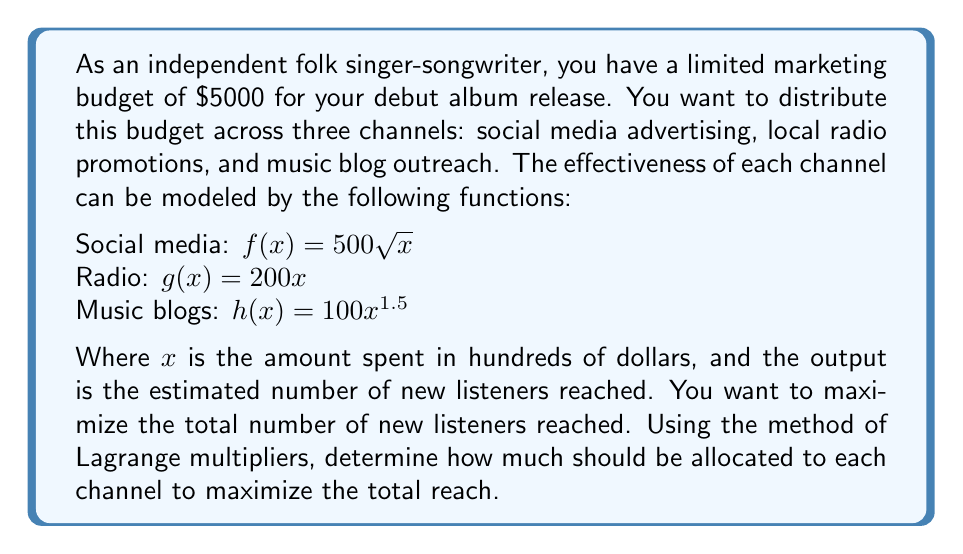What is the answer to this math problem? Let's approach this step-by-step using the method of Lagrange multipliers:

1) Let $x$, $y$, and $z$ represent the amount spent (in hundreds of dollars) on social media, radio, and music blogs respectively.

2) Our objective function is:
   $$F(x,y,z) = 500\sqrt{x} + 200y + 100z^{1.5}$$

3) Our constraint is:
   $$x + y + z = 50$$ (since the total budget is $5000 = 50 * 100$)

4) We form the Lagrangian:
   $$L(x,y,z,\lambda) = 500\sqrt{x} + 200y + 100z^{1.5} - \lambda(x + y + z - 50)$$

5) Now we take partial derivatives and set them equal to zero:

   $$\frac{\partial L}{\partial x} = \frac{250}{\sqrt{x}} - \lambda = 0$$
   $$\frac{\partial L}{\partial y} = 200 - \lambda = 0$$
   $$\frac{\partial L}{\partial z} = 150\sqrt{z} - \lambda = 0$$
   $$\frac{\partial L}{\partial \lambda} = x + y + z - 50 = 0$$

6) From the second equation, we get $\lambda = 200$.

7) Substituting this into the first and third equations:

   $$\frac{250}{\sqrt{x}} = 200$$ gives $$x = (\frac{250}{200})^2 = 1.5625$$
   $$150\sqrt{z} = 200$$ gives $$z = (\frac{200}{150})^2 = 1.7778$$

8) Using these in the constraint equation:

   $$1.5625 + y + 1.7778 = 50$$
   $$y = 46.6597$$

9) Converting back to actual dollar amounts:
   Social media: $156.25
   Radio: $4,665.97
   Music blogs: $177.78
Answer: Social media: $156.25, Radio: $4,665.97, Music blogs: $177.78 